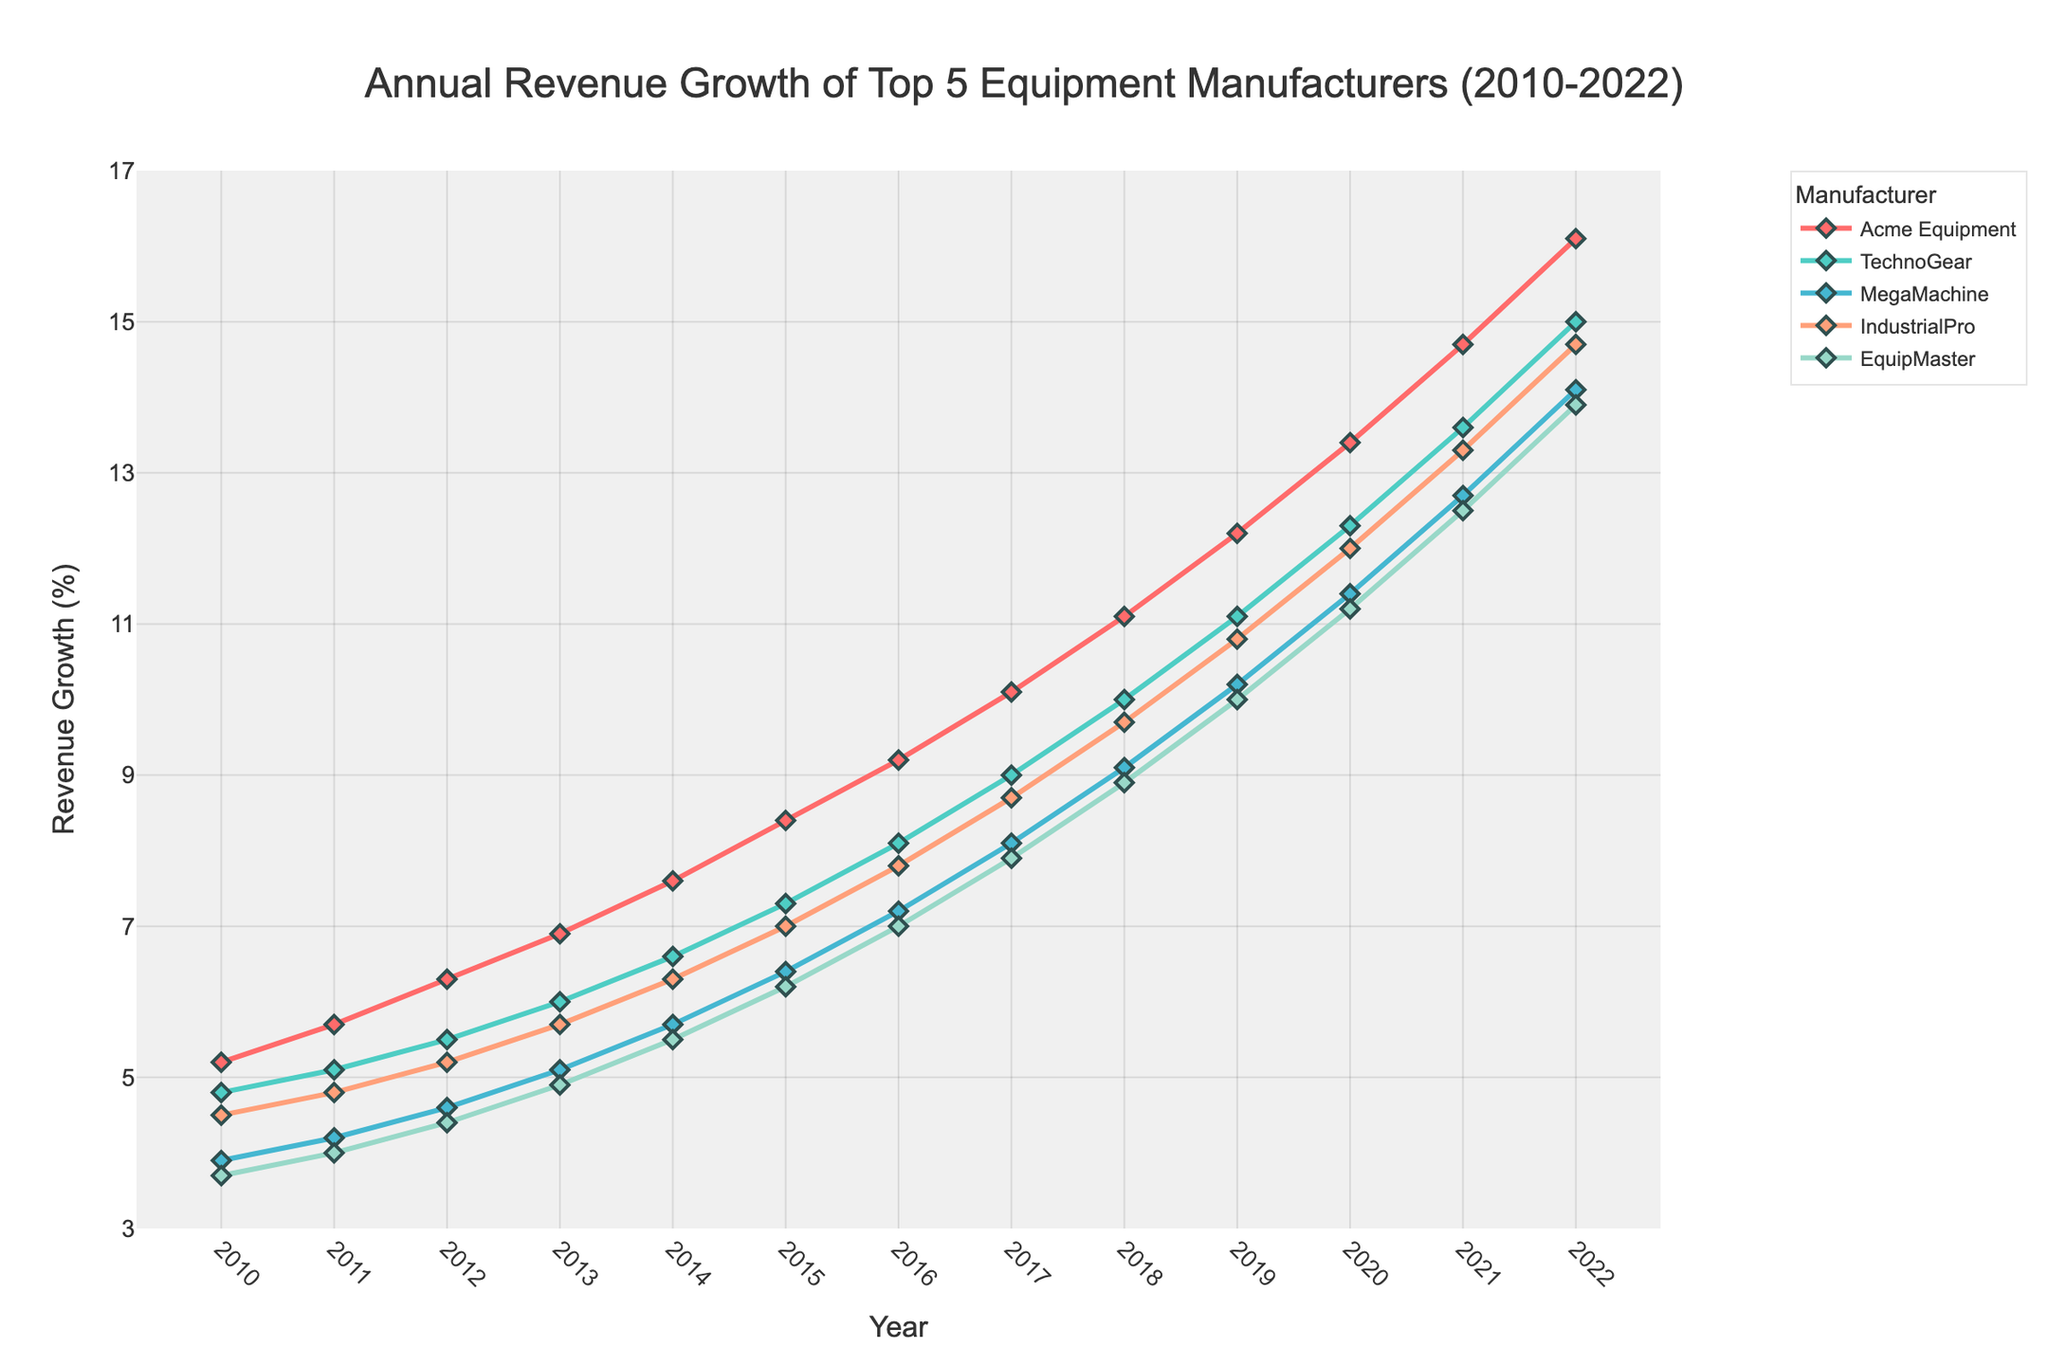Which manufacturer had the highest revenue growth in 2022? Look at the data points for each manufacturer in 2022 and compare their values. Acme Equipment has the highest value of 16.1%
Answer: Acme Equipment Which manufacturer showed the lowest revenue growth in 2010? Look at the data points for each manufacturer in 2010 and compare their values. EquipMaster has the lowest value of 3.7%
Answer: EquipMaster How much did TechnoGear's revenue grow between 2010 and 2022? Subtract the 2010 value of TechnoGear from the 2022 value: 15.0 - 4.8 = 10.2%
Answer: 10.2% What is the average revenue growth of IndustrialPro from 2010 to 2022? Sum the revenue growth values for IndustrialPro from each year, then divide by the number of years: (4.5+4.8+5.2+5.7+6.3+7.0+7.8+8.7+9.7+10.8+12.0+13.3+14.7)/13 = 8.3%
Answer: 8.3% Which manufacturer had the highest increase in revenue growth from 2010 to 2011? Calculate the differences between the 2010 and 2011 values for each manufacturer: (5.7-5.2, 5.1-4.8, 4.2-3.9, 4.8-4.5, 4.0-3.7) = (0.5, 0.3, 0.3, 0.3, 0.3). Acme Equipment had the highest increase of 0.5%
Answer: Acme Equipment Did MegaMachine's revenue growth ever surpass TechnoGear's between 2010 and 2022? Compare the revenue growth values of MegaMachine and TechnoGear for each year. MegaMachine's revenue growth was never greater than TechnoGear's during this period
Answer: No What is the trend of revenue growth for EquipMaster from 2010 to 2022? Observe the line for EquipMaster from 2010 to 2022. It shows a steadily increasing trend over the years
Answer: Increasing trend In which year did Acme Equipment's revenue growth first exceed 10%? Look at the data points for Acme Equipment and find the year it first exceeds 10%. The first year is 2017
Answer: 2017 Compare the revenue growth of TechnoGear and IndustrialPro in 2020. Which one was higher? Look at the data points for TechnoGear and IndustrialPro in 2020. TechnoGear's value is 12.3 and IndustrialPro's value is 12.0, so TechnoGear's revenue growth is higher
Answer: TechnoGear 